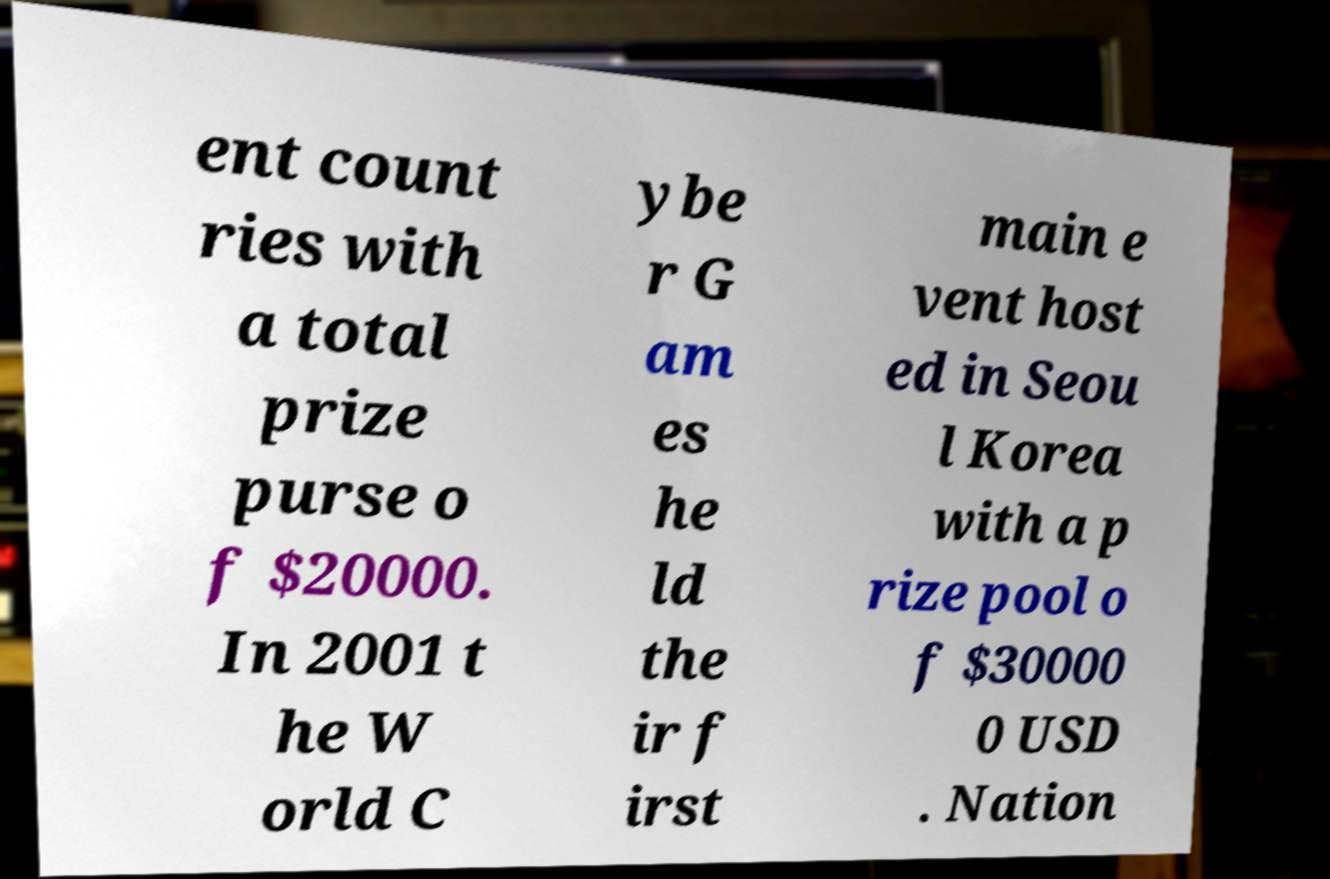Could you assist in decoding the text presented in this image and type it out clearly? ent count ries with a total prize purse o f $20000. In 2001 t he W orld C ybe r G am es he ld the ir f irst main e vent host ed in Seou l Korea with a p rize pool o f $30000 0 USD . Nation 